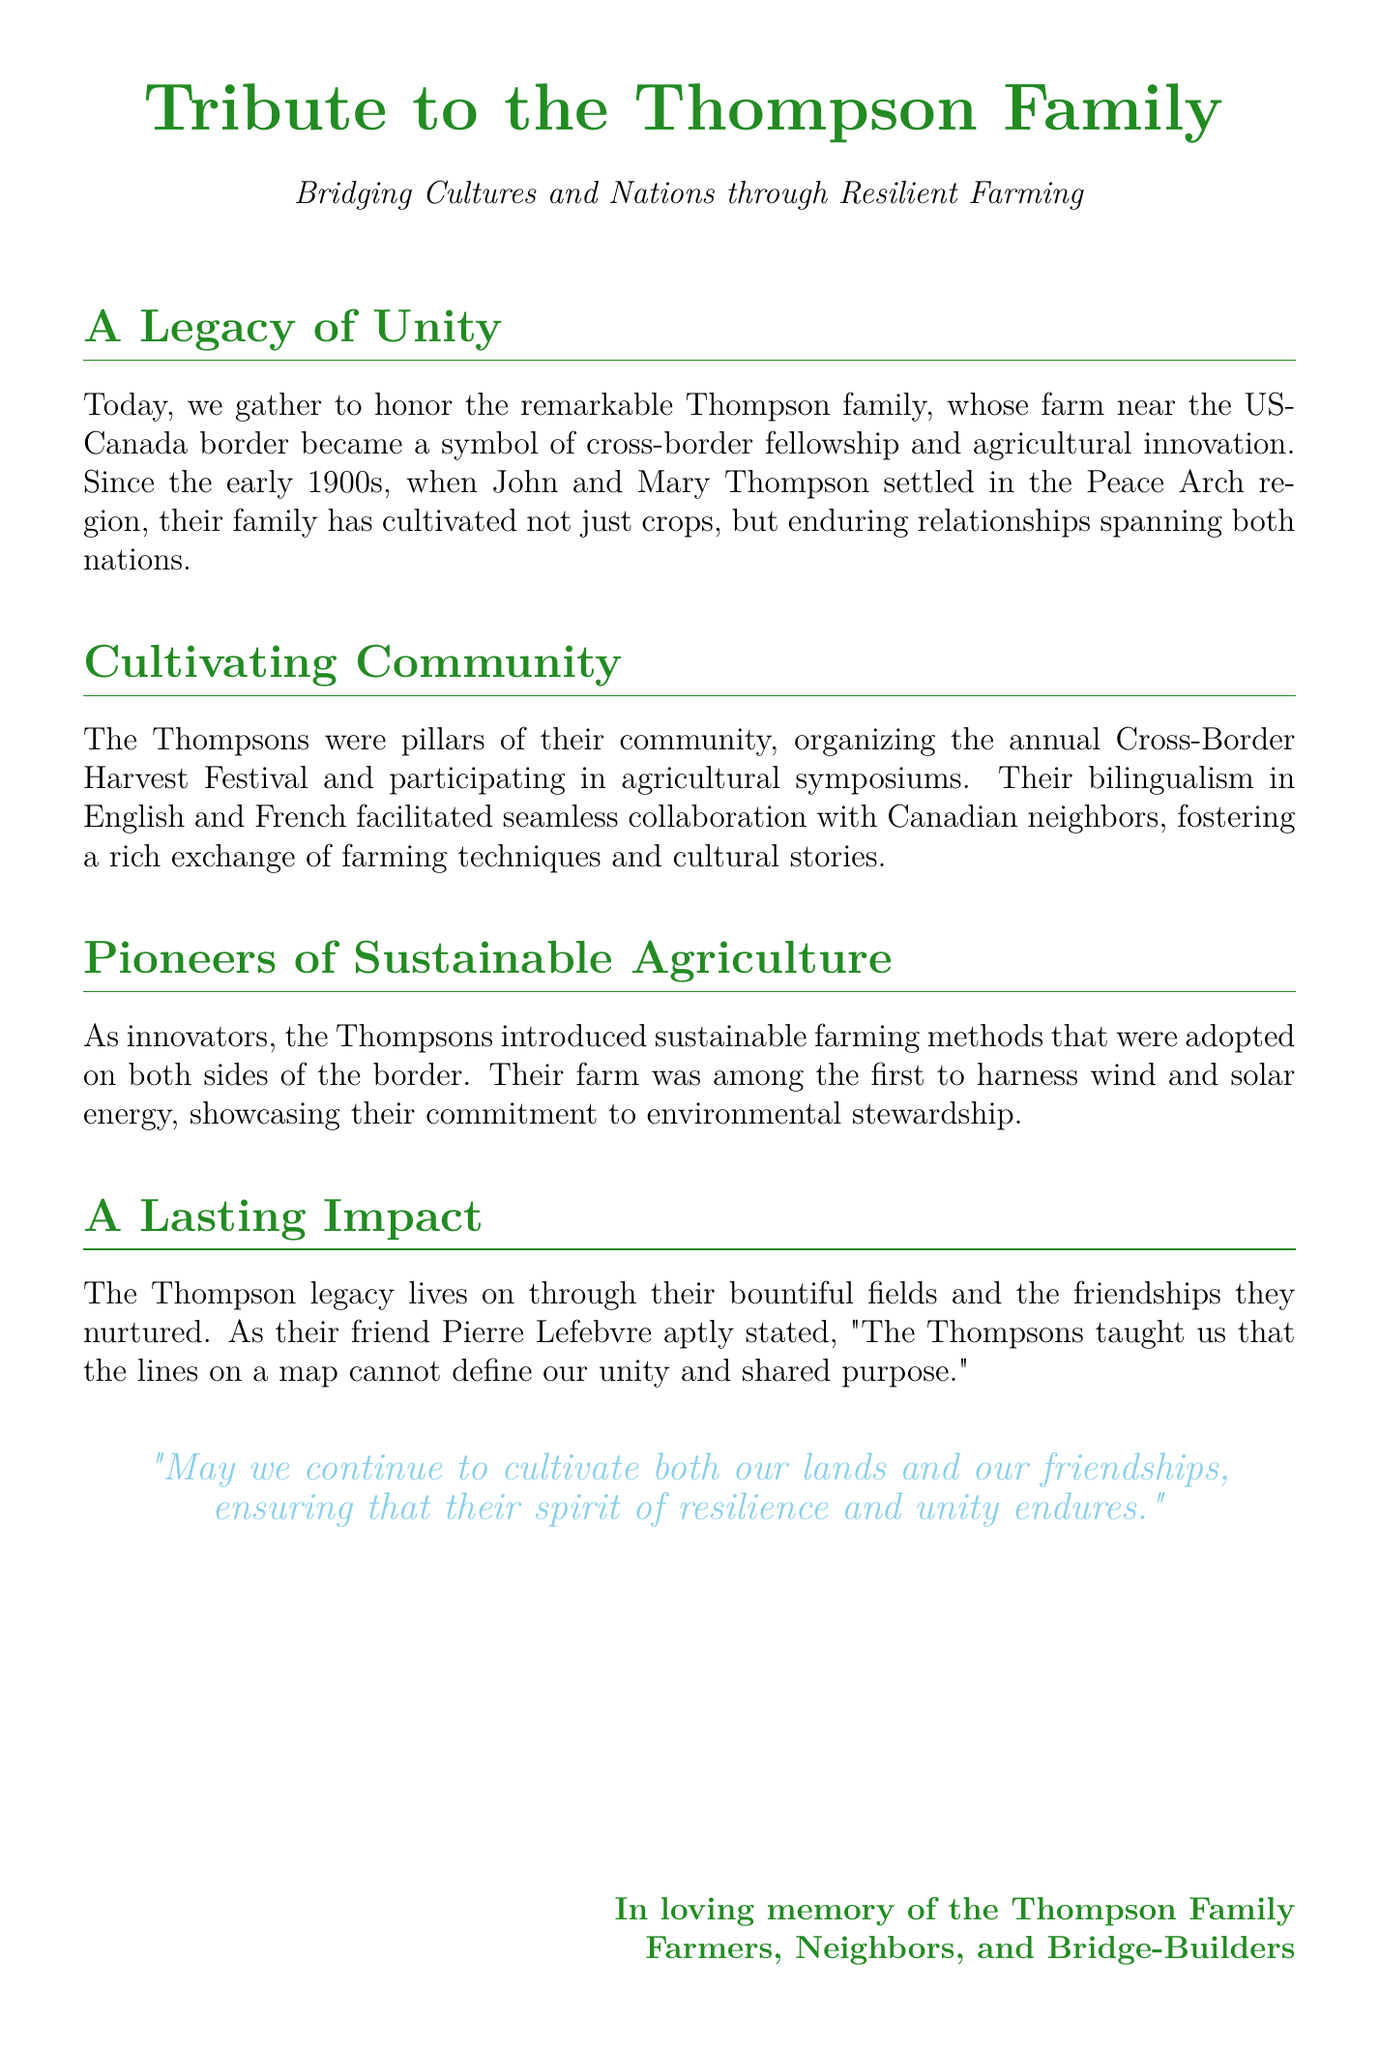What is the name of the family being honored? The document states that the family being honored is the Thompson family.
Answer: Thompson family In what region did John and Mary Thompson settle? The document mentions that John and Mary Thompson settled in the Peace Arch region.
Answer: Peace Arch region When did the Thompson family begin their farming journey? The document indicates that the Thompson family began their farming journey in the early 1900s.
Answer: early 1900s What festival did the Thompsons organize annually? The document states that the Thompsons organized the annual Cross-Border Harvest Festival.
Answer: Cross-Border Harvest Festival Which farming methods did the Thompsons pioneer? The document notes that the Thompsons introduced sustainable farming methods.
Answer: sustainable farming methods Which languages did the Thompsons speak? The document mentions that the Thompsons were bilingual in English and French.
Answer: English and French What type of energy did the Thompsons harness on their farm? The document states that the Thompsons' farm was among the first to harness wind and solar energy.
Answer: wind and solar energy What did Pierre Lefebvre say about the Thompsons? The document quotes Pierre Lefebvre, stating that the Thompsons taught unity beyond borders.
Answer: unity and shared purpose What is the concluding message of the tribute? The document concludes with a message about cultivating lands and friendships.
Answer: cultivating both our lands and our friendships What is the overall theme of the eulogy? The document emphasizes the theme of bridging cultures and nations through farming.
Answer: bridging cultures and nations 